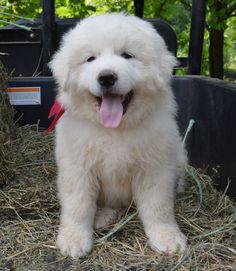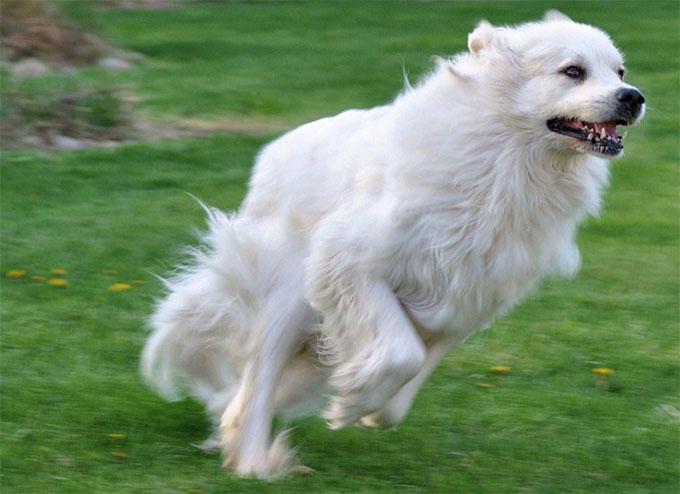The first image is the image on the left, the second image is the image on the right. Given the left and right images, does the statement "The puppy on the left image is showing its tongue" hold true? Answer yes or no. Yes. 